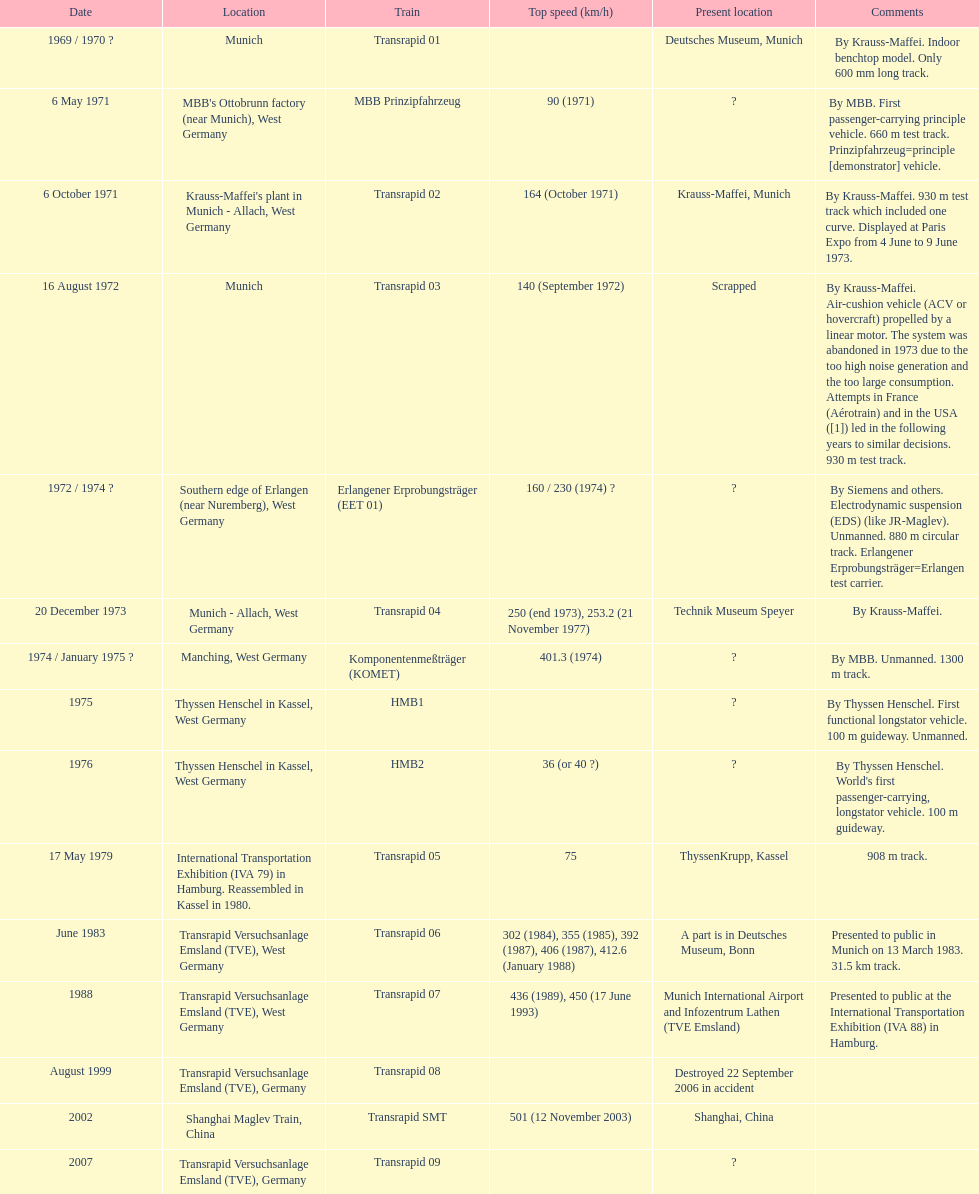High noise generation and too large consumption led to what train being scrapped? Transrapid 03. 